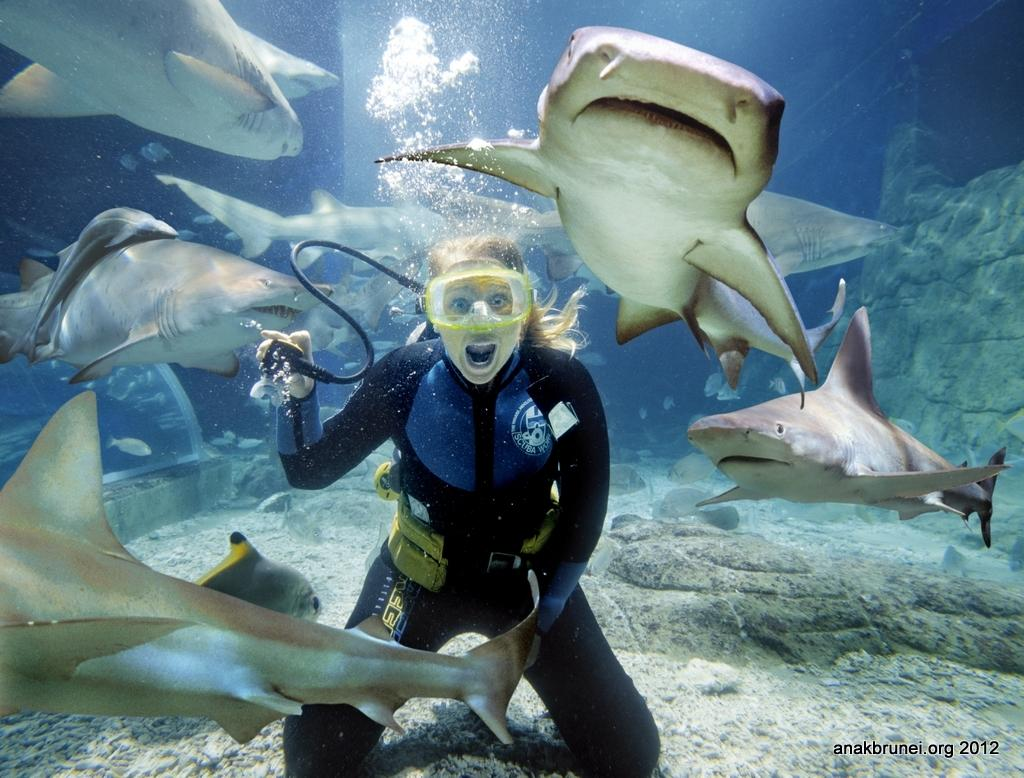Who is in the image? There is a woman in the image. Where is the woman located? The woman is underwater. What is present around the woman? Sharks are present around the woman. What is the woman wearing? The woman is wearing a black color swimming suit. What type of wool is the woman using to protect herself from the sharks? There is no wool present in the image, and the woman is not using any material to protect herself from the sharks. 